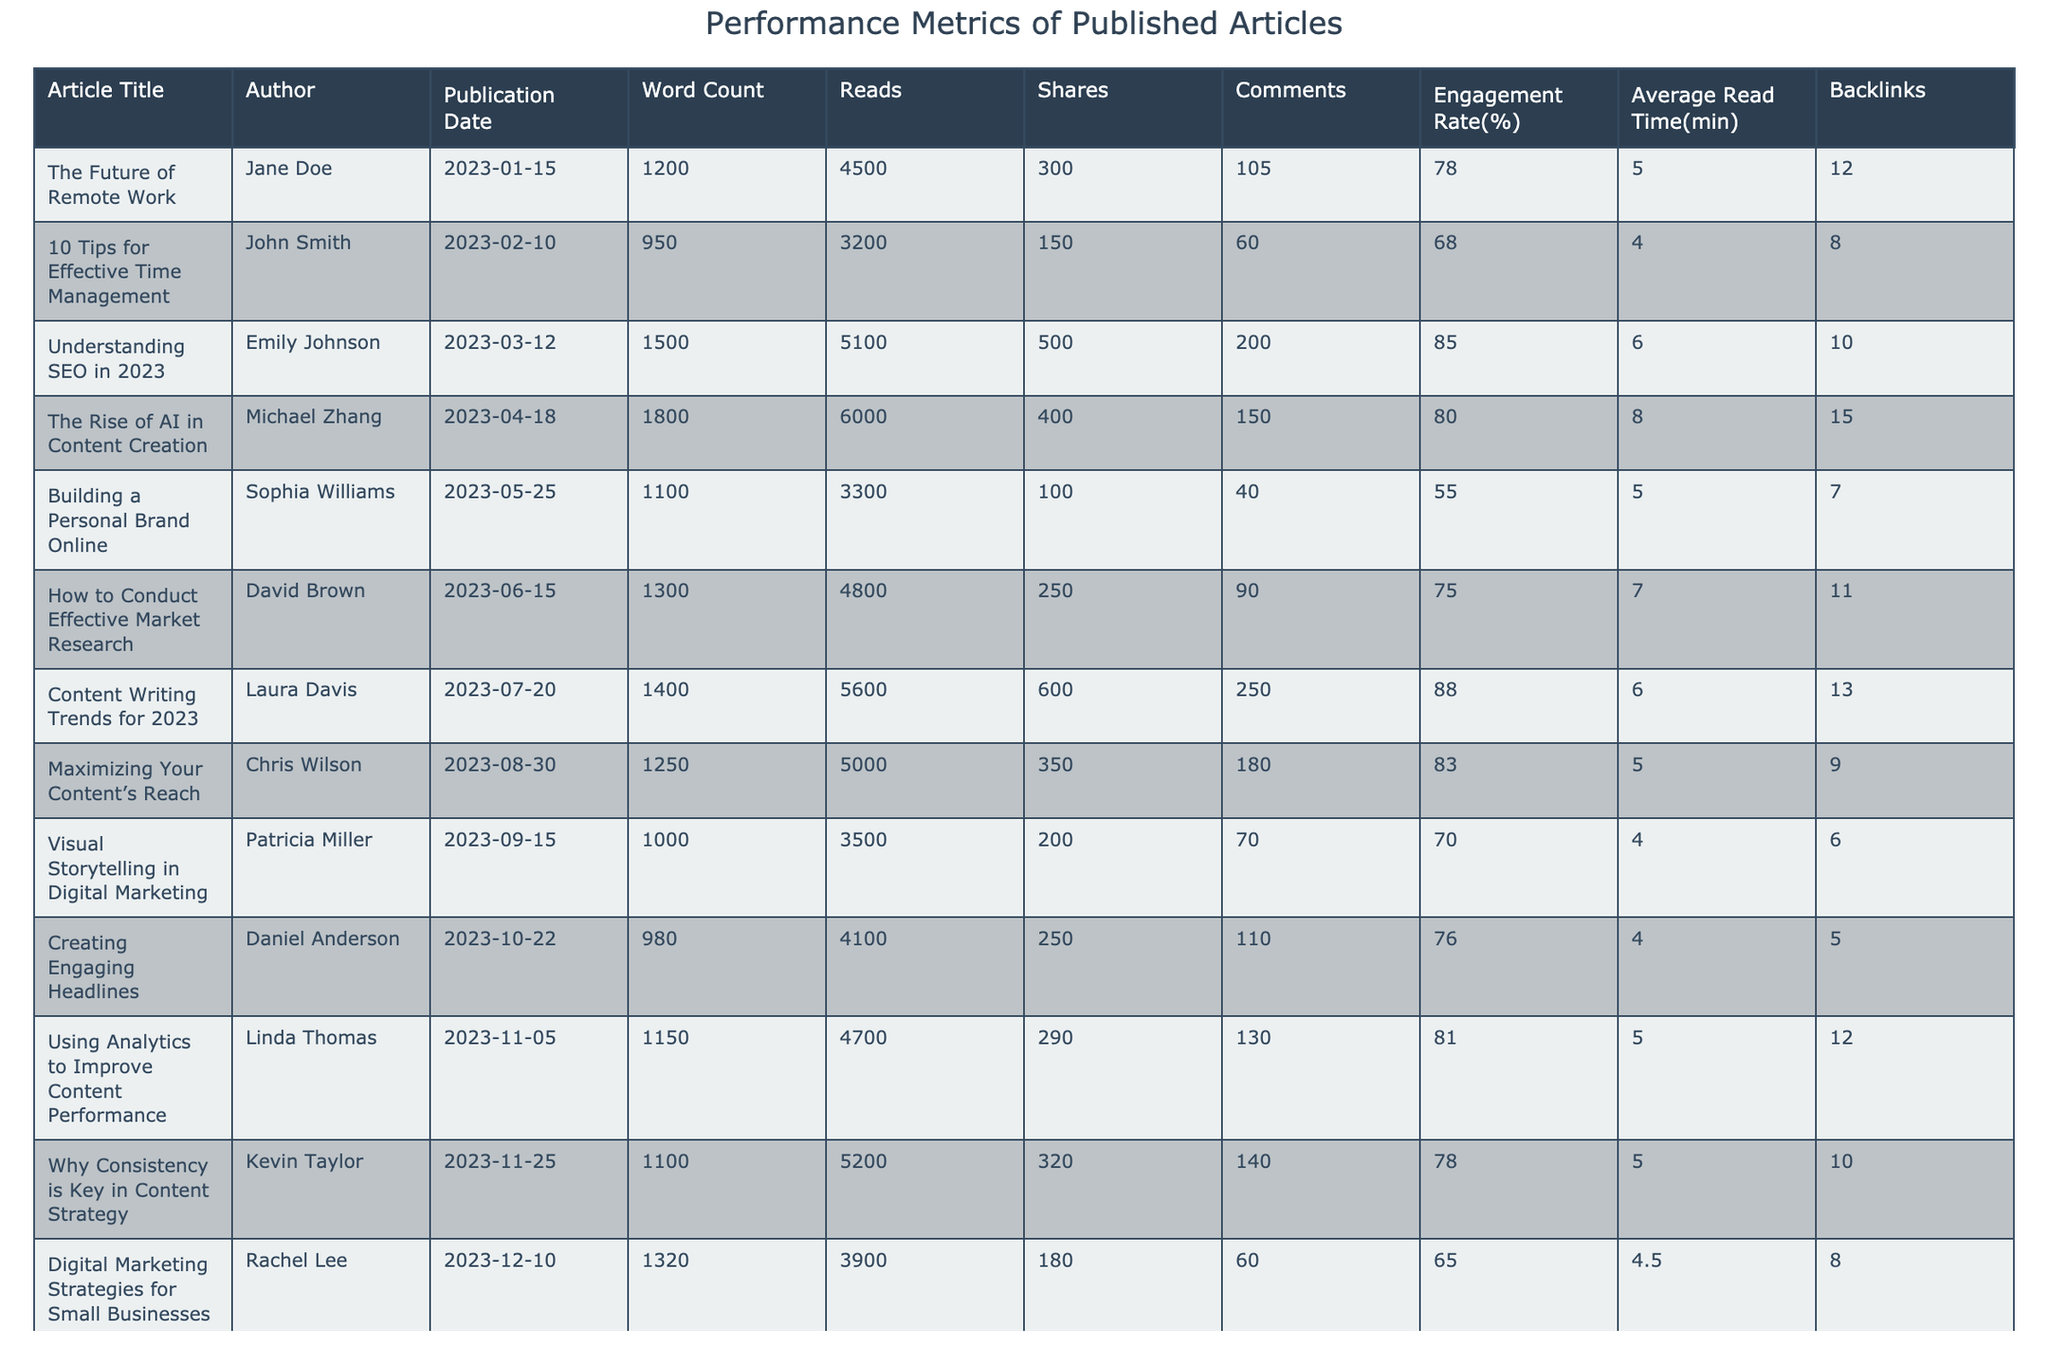What is the article with the highest number of reads? By scanning the "Reads" column in the table, I identify that "The Rise of AI in Content Creation" has the highest reads at 6000.
Answer: "The Rise of AI in Content Creation" Which article has the most shares? Looking at the "Shares" column, I see that "Understanding SEO in 2023" has the highest shares with 500.
Answer: "Understanding SEO in 2023" What is the average engagement rate of all articles? I calculate the average engagement rate by summing all rates (78 + 68 + 85 + 80 + 55 + 75 + 88 + 83 + 70 + 76 + 81 + 78 + 65 + 82), which totals 1109. There are 14 articles, so the average engagement rate is 1109 / 14 = 79.21%.
Answer: 79.21% How many articles have an engagement rate above 80%? I check the engagement rates and find that the articles "Understanding SEO in 2023," "The Rise of AI in Content Creation," "Content Writing Trends for 2023," and "Leveraging Social Media for Content Distribution" all exceed 80%. This gives me a total of 4 articles.
Answer: 4 What is the relationship between word count and number of reads in the top three articles? The top three articles by reads are: "The Rise of AI in Content Creation" (1800 words, 6000 reads), "Understanding SEO in 2023" (1500 words, 5100 reads), and "Content Writing Trends for 2023" (1400 words, 5600 reads). Higher word count does not guarantee higher reads, as the highest read count has the most words, while the second highest has more reads despite fewer words than the first.
Answer: Mixed relationship What is the total number of comments across all articles? I sum up the comments (105 + 60 + 200 + 150 + 40 + 90 + 250 + 180 + 70 + 110 + 130 + 140 + 60 + 190), which totals 1,685 comments.
Answer: 1685 Is there an article with a higher average read time than 6 minutes? By examining the "Average Read Time" column, I see that "Understanding SEO in 2023," "The Rise of AI in Content Creation," "How to Conduct Effective Market Research," "Content Writing Trends for 2023," and "Leveraging Social Media for Content Distribution" all have read times above 6 minutes. Therefore, the answer is yes.
Answer: Yes Which author has written the article with the lowest number of reads? I look for the article with the least reads, which is "Building a Personal Brand Online" by Sophia Williams with 3300 reads.
Answer: Sophia Williams What was the average word count of the articles with engagement rates below 70%? I find the articles with engagement rates below 70%: "Building a Personal Brand Online" (1100 words), "Visual Storytelling in Digital Marketing" (1000 words), and "Digital Marketing Strategies for Small Businesses" (1320 words). Their total word count is 1100 + 1000 + 1320 = 3420, and divided by 3 gives an average of 1140.
Answer: 1140 How many articles were published in the second half of the year? I examine the "Publication Date" column and identify the entries from July to December. There are 7 articles published during this period.
Answer: 7 